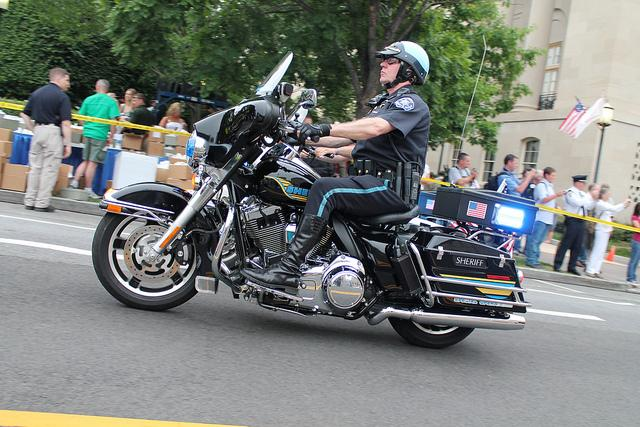What is the name of the nation with the flag in this picture?

Choices:
A) united kingdom
B) south korea
C) canada
D) united states united states 